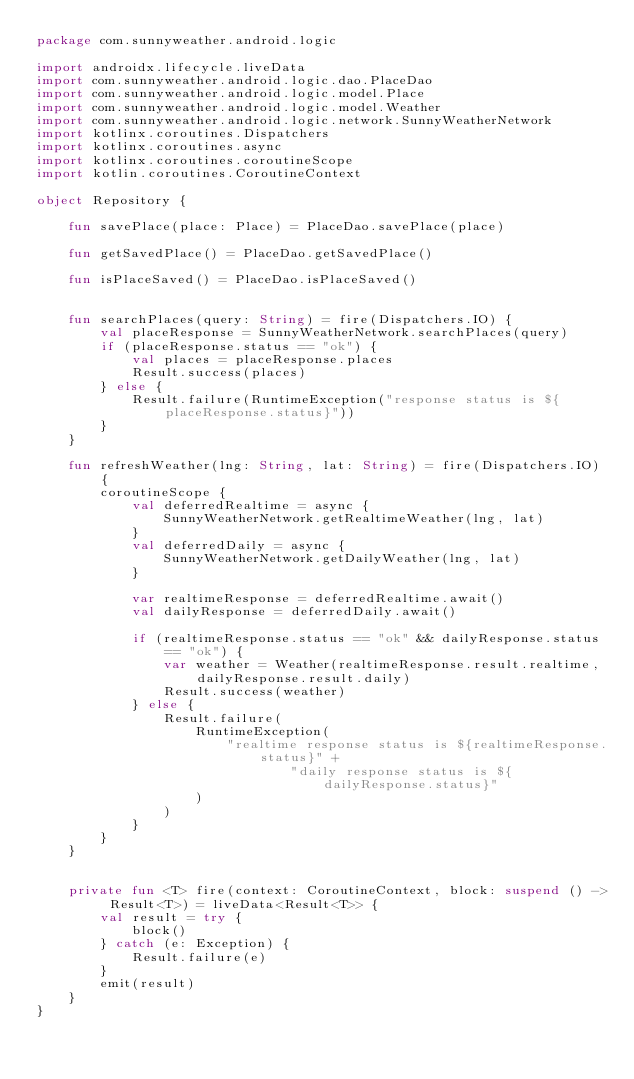<code> <loc_0><loc_0><loc_500><loc_500><_Kotlin_>package com.sunnyweather.android.logic

import androidx.lifecycle.liveData
import com.sunnyweather.android.logic.dao.PlaceDao
import com.sunnyweather.android.logic.model.Place
import com.sunnyweather.android.logic.model.Weather
import com.sunnyweather.android.logic.network.SunnyWeatherNetwork
import kotlinx.coroutines.Dispatchers
import kotlinx.coroutines.async
import kotlinx.coroutines.coroutineScope
import kotlin.coroutines.CoroutineContext

object Repository {

    fun savePlace(place: Place) = PlaceDao.savePlace(place)

    fun getSavedPlace() = PlaceDao.getSavedPlace()

    fun isPlaceSaved() = PlaceDao.isPlaceSaved()


    fun searchPlaces(query: String) = fire(Dispatchers.IO) {
        val placeResponse = SunnyWeatherNetwork.searchPlaces(query)
        if (placeResponse.status == "ok") {
            val places = placeResponse.places
            Result.success(places)
        } else {
            Result.failure(RuntimeException("response status is ${placeResponse.status}"))
        }
    }

    fun refreshWeather(lng: String, lat: String) = fire(Dispatchers.IO) {
        coroutineScope {
            val deferredRealtime = async {
                SunnyWeatherNetwork.getRealtimeWeather(lng, lat)
            }
            val deferredDaily = async {
                SunnyWeatherNetwork.getDailyWeather(lng, lat)
            }

            var realtimeResponse = deferredRealtime.await()
            val dailyResponse = deferredDaily.await()

            if (realtimeResponse.status == "ok" && dailyResponse.status == "ok") {
                var weather = Weather(realtimeResponse.result.realtime, dailyResponse.result.daily)
                Result.success(weather)
            } else {
                Result.failure(
                    RuntimeException(
                        "realtime response status is ${realtimeResponse.status}" +
                                "daily response status is ${dailyResponse.status}"
                    )
                )
            }
        }
    }


    private fun <T> fire(context: CoroutineContext, block: suspend () -> Result<T>) = liveData<Result<T>> {
        val result = try {
            block()
        } catch (e: Exception) {
            Result.failure(e)
        }
        emit(result)
    }
}</code> 